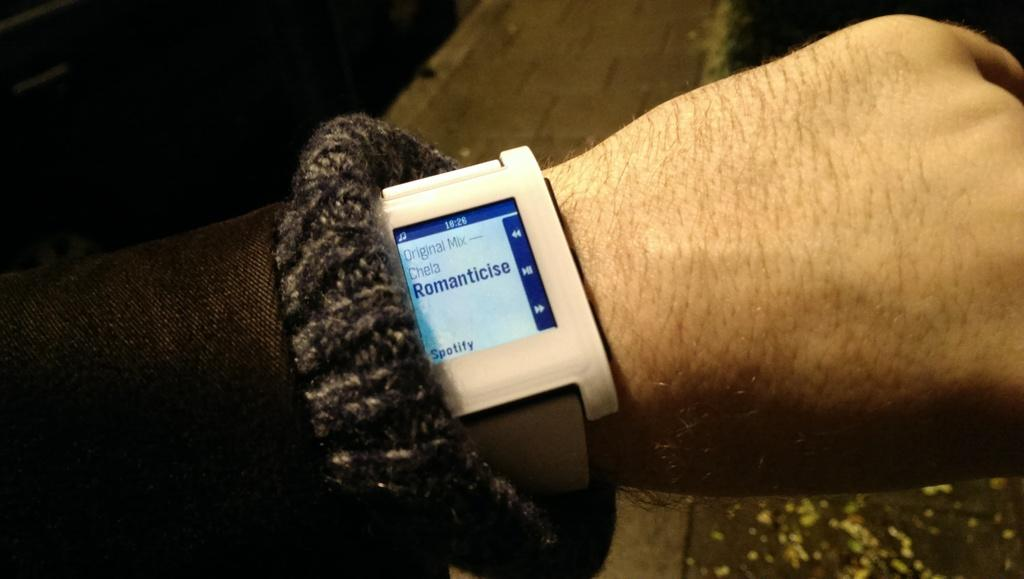<image>
Provide a brief description of the given image. Someone's smart watch has Spotify open and says Romanticise. 